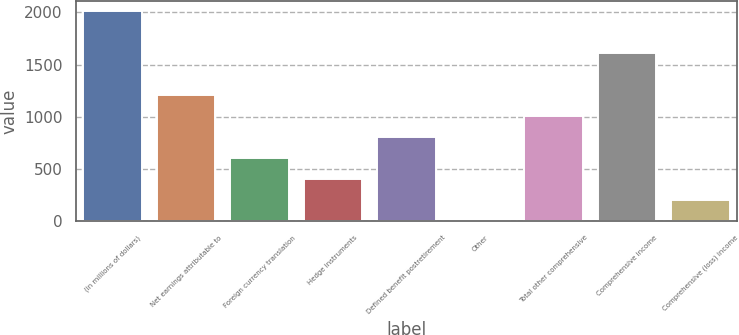Convert chart. <chart><loc_0><loc_0><loc_500><loc_500><bar_chart><fcel>(in millions of dollars)<fcel>Net earnings attributable to<fcel>Foreign currency translation<fcel>Hedge instruments<fcel>Defined benefit postretirement<fcel>Other<fcel>Total other comprehensive<fcel>Comprehensive income<fcel>Comprehensive (loss) income<nl><fcel>2013<fcel>1208.4<fcel>604.95<fcel>403.8<fcel>806.1<fcel>1.5<fcel>1007.25<fcel>1610.7<fcel>202.65<nl></chart> 